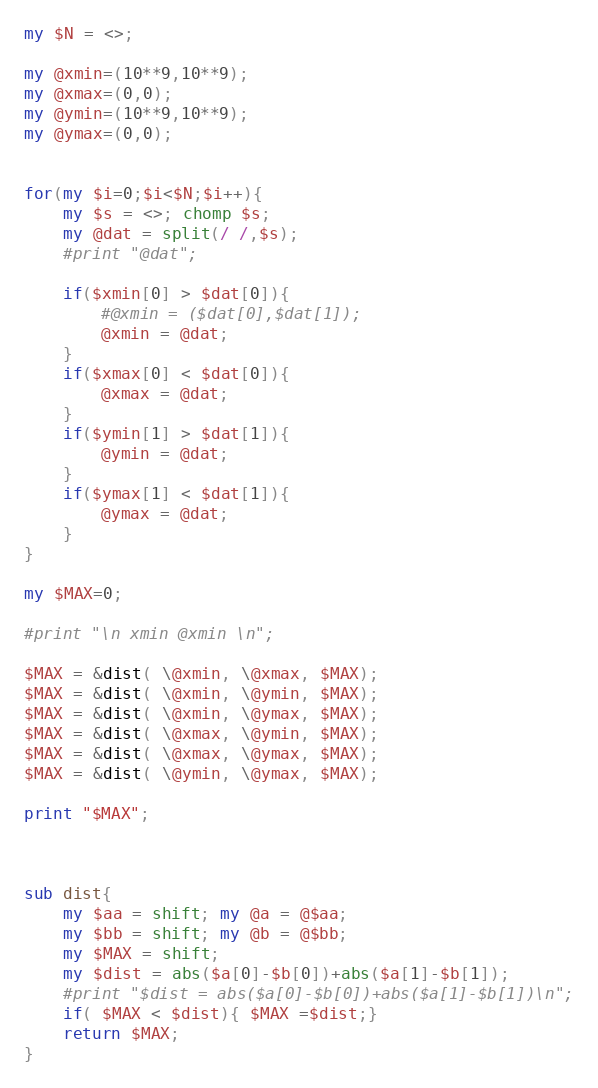Convert code to text. <code><loc_0><loc_0><loc_500><loc_500><_Perl_>my $N = <>;

my @xmin=(10**9,10**9);
my @xmax=(0,0);
my @ymin=(10**9,10**9);
my @ymax=(0,0);


for(my $i=0;$i<$N;$i++){
    my $s = <>; chomp $s; 
    my @dat = split(/ /,$s);
    #print "@dat";
    
    if($xmin[0] > $dat[0]){
        #@xmin = ($dat[0],$dat[1]);
        @xmin = @dat;
    }
    if($xmax[0] < $dat[0]){
        @xmax = @dat;
    }
    if($ymin[1] > $dat[1]){
        @ymin = @dat;
    }
    if($ymax[1] < $dat[1]){
        @ymax = @dat;
    }
}

my $MAX=0;

#print "\n xmin @xmin \n";

$MAX = &dist( \@xmin, \@xmax, $MAX);
$MAX = &dist( \@xmin, \@ymin, $MAX);
$MAX = &dist( \@xmin, \@ymax, $MAX);
$MAX = &dist( \@xmax, \@ymin, $MAX);
$MAX = &dist( \@xmax, \@ymax, $MAX);
$MAX = &dist( \@ymin, \@ymax, $MAX);

print "$MAX";

  

sub dist{
    my $aa = shift; my @a = @$aa;
    my $bb = shift; my @b = @$bb;
    my $MAX = shift;
    my $dist = abs($a[0]-$b[0])+abs($a[1]-$b[1]);
    #print "$dist = abs($a[0]-$b[0])+abs($a[1]-$b[1])\n";
    if( $MAX < $dist){ $MAX =$dist;}
    return $MAX;
}</code> 